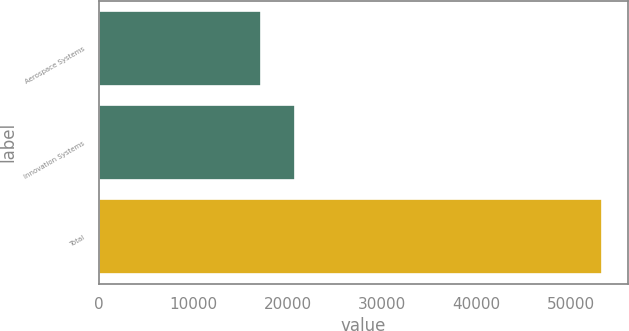Convert chart to OTSL. <chart><loc_0><loc_0><loc_500><loc_500><bar_chart><fcel>Aerospace Systems<fcel>Innovation Systems<fcel>Total<nl><fcel>17135<fcel>20749.8<fcel>53283<nl></chart> 